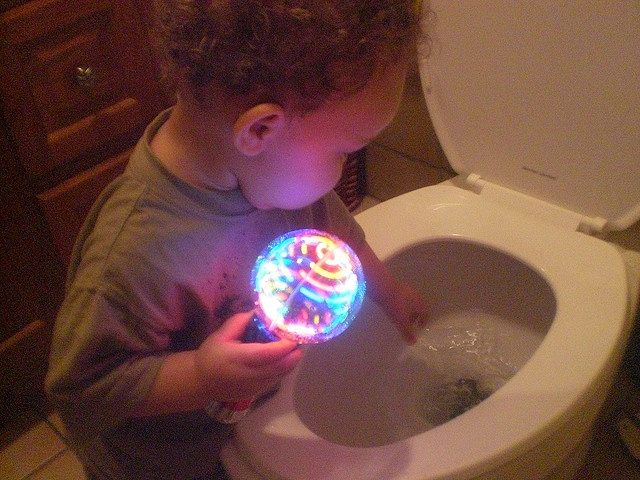Describe the objects in this image and their specific colors. I can see toilet in black, gray, tan, and maroon tones and people in black, maroon, and purple tones in this image. 